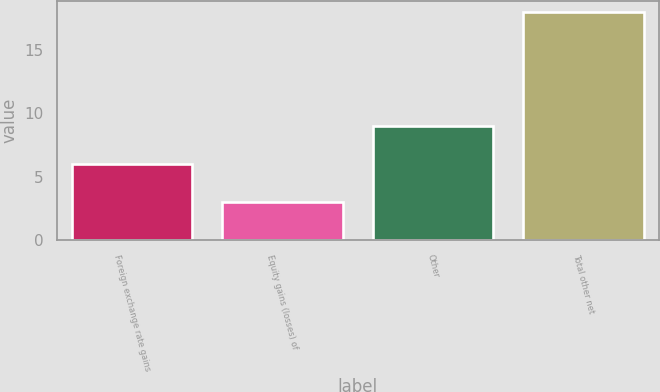Convert chart. <chart><loc_0><loc_0><loc_500><loc_500><bar_chart><fcel>Foreign exchange rate gains<fcel>Equity gains (losses) of<fcel>Other<fcel>Total other net<nl><fcel>6<fcel>3<fcel>9<fcel>18<nl></chart> 